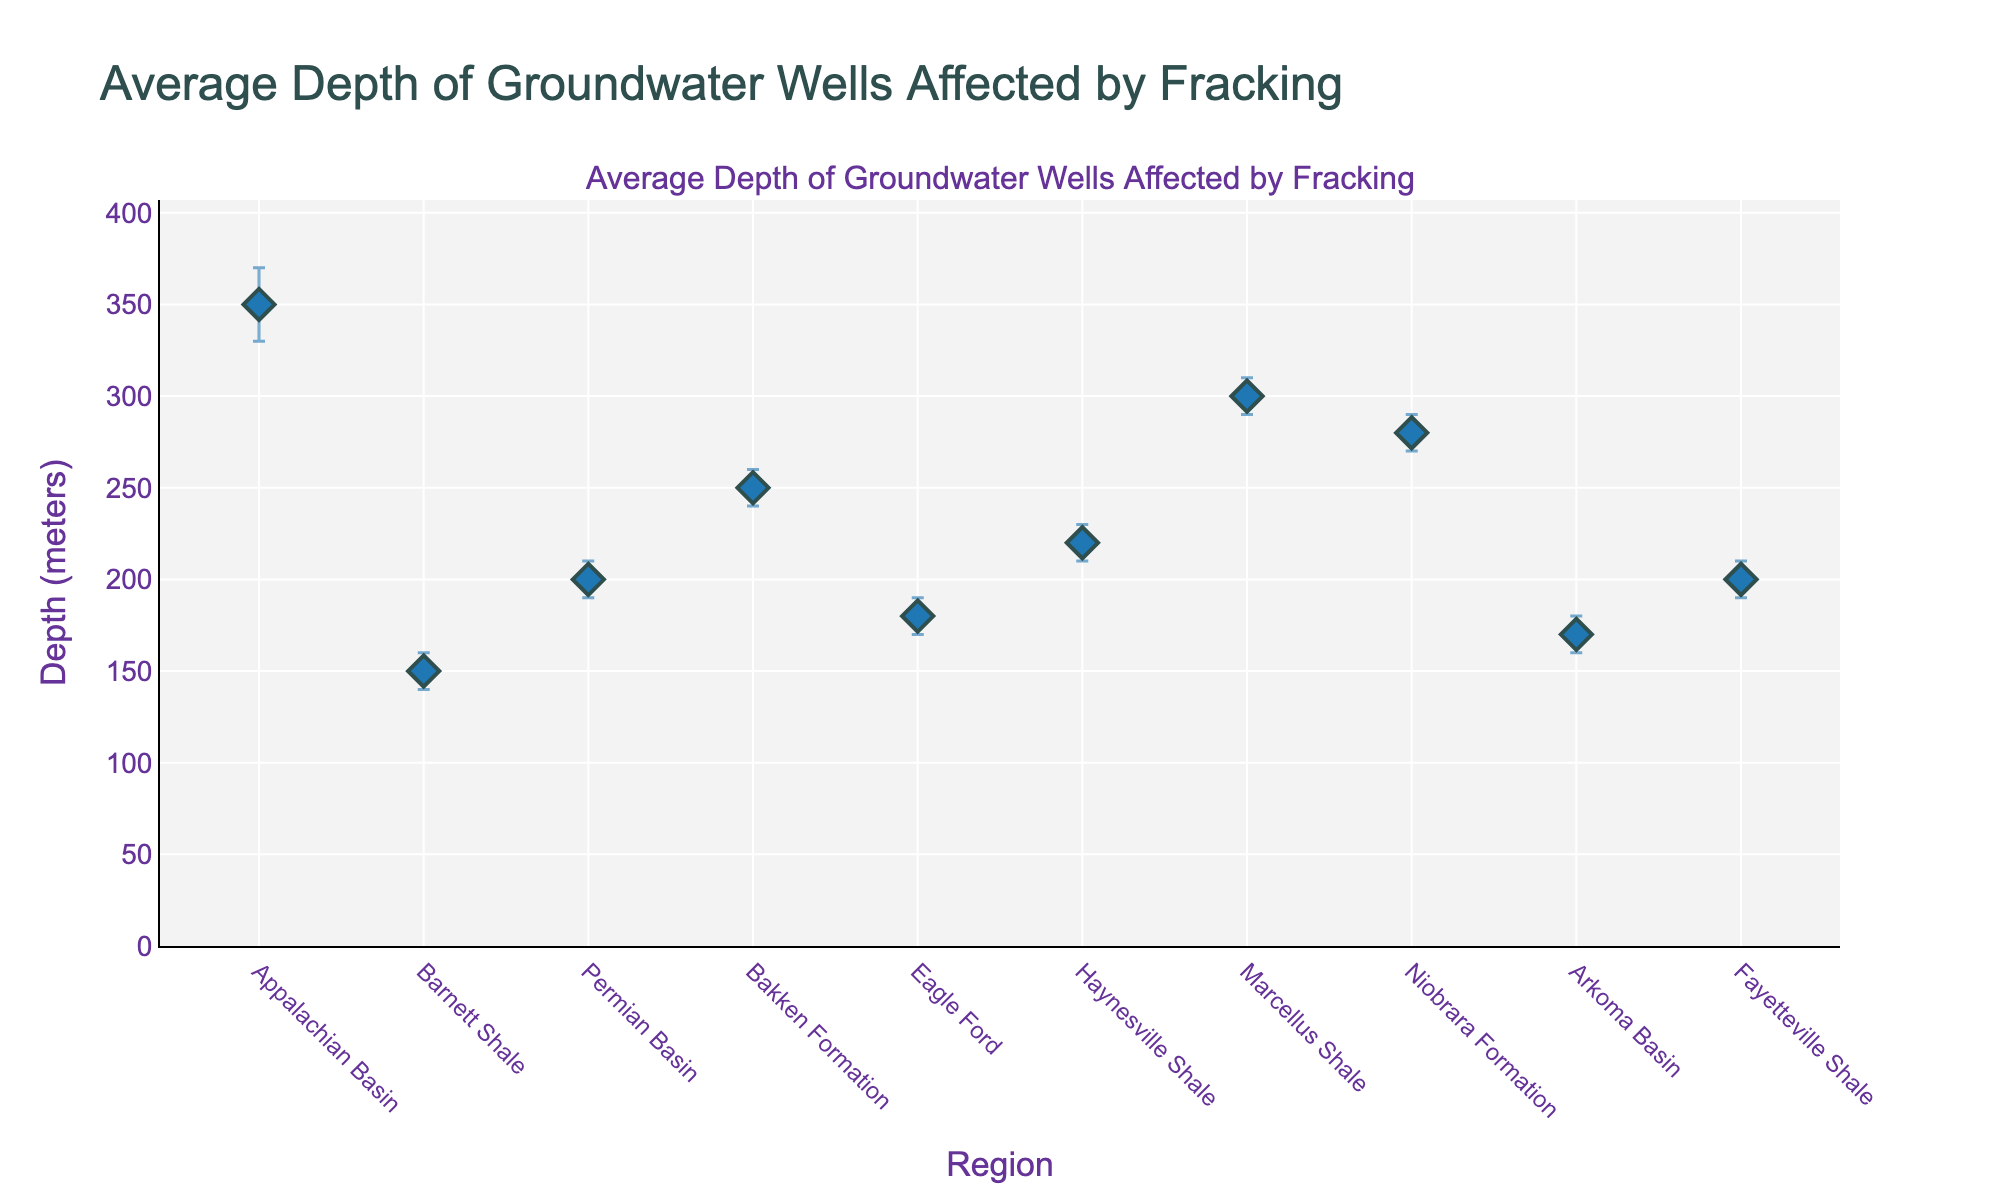what is the title of the plot? The title of a plot is usually displayed at the top. In this case, it reads "Average Depth of Groundwater Wells Affected by Fracking".
Answer: Average Depth of Groundwater Wells Affected by Fracking How many regions are displayed in the plot? Count the unique markers, each representing a region. In this figure, there are markers for each of the 10 regions.
Answer: 10 Which region has the shallowest mean depth? Look at the y-axis values of all the markers and identify the one closest to the bottom. Barnett Shale has the lowest mean depth, which is 150 meters.
Answer: Barnett Shale Which regions have a mean depth greater than 250 meters? Locate the markers above the 250-meter mark on the y-axis. Both Appalachian Basin (350 meters) and Marcellus Shale (300 meters) have mean depths above 250 meters.
Answer: Appalachian Basin, Marcellus Shale Which region has the smallest confidence interval? Assess the length of the error bars for all regions and identify the shortest one. Barnett Shale has the smallest confidence interval from 140 to 160 meters (a range of 20 meters).
Answer: Barnett Shale What is the range of the confidence interval for the Eagle Ford region? Check the lower and upper bounds of the error bars for the Eagle Ford region. The lower CI is 170 meters and the upper CI is 190 meters, so the range is 190 - 170 = 20 meters.
Answer: 20 meters What is the difference in mean depth between the Permian Basin and the Niobrara Formation? Look at the mean depths for the Permian Basin (200 meters) and Niobrara Formation (280 meters) and find the difference: 280 - 200 = 80 meters.
Answer: 80 meters Which regions have overlapping confidence intervals with the Bakken Formation? Identify regions whose error bars overlap with Bakken Formation (240 to 260 meters). Both Niobrara Formation (270 to 290 meters) and Haynesville Shale (210 to 230 meters) partially overlap with Bakken Formation.
Answer: Niobrara Formation, Haynesville Shale What is the median mean depth of all regions? List the mean depths and find the median: [150, 170, 180, 200, 200, 220, 250, 280, 300, 350]. The median value (5th and 6th) for 10 values is (200+220)/2 = 210 meters.
Answer: 210 meters 